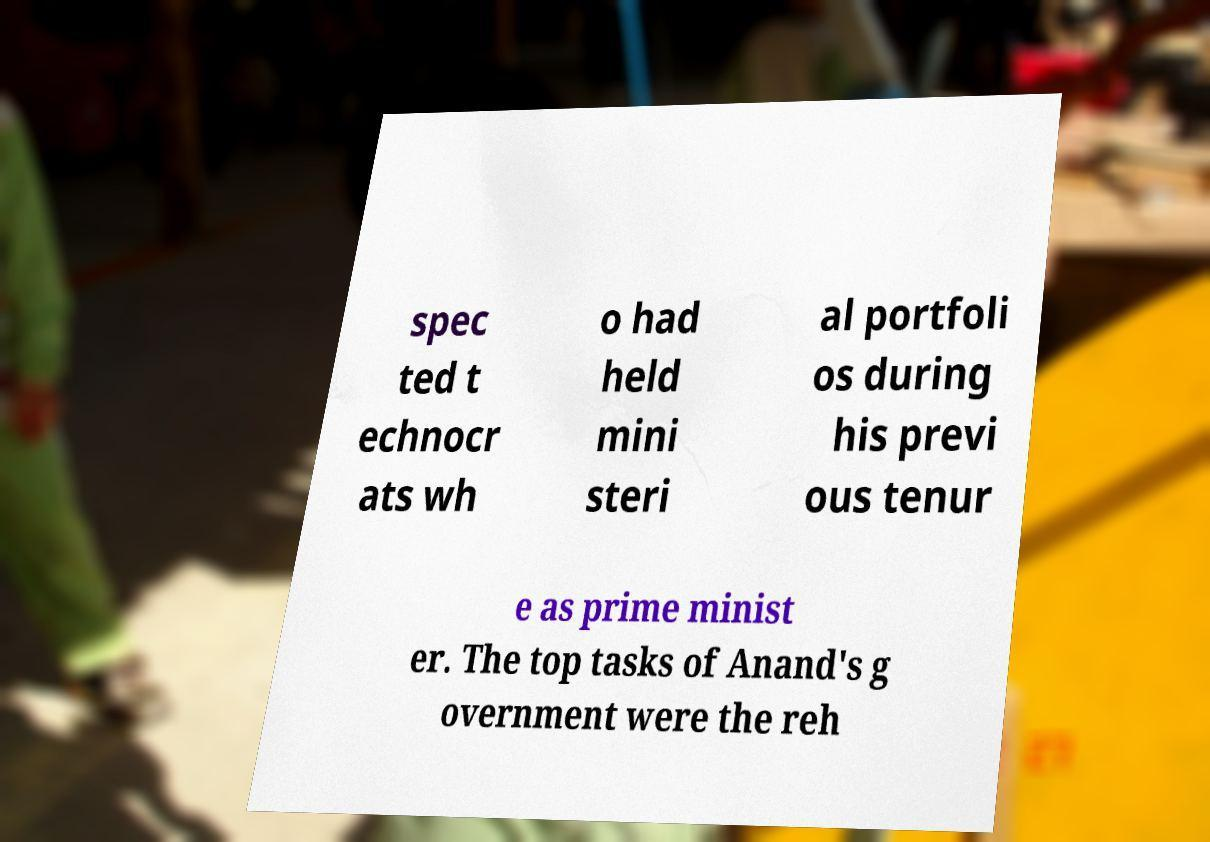Please identify and transcribe the text found in this image. spec ted t echnocr ats wh o had held mini steri al portfoli os during his previ ous tenur e as prime minist er. The top tasks of Anand's g overnment were the reh 